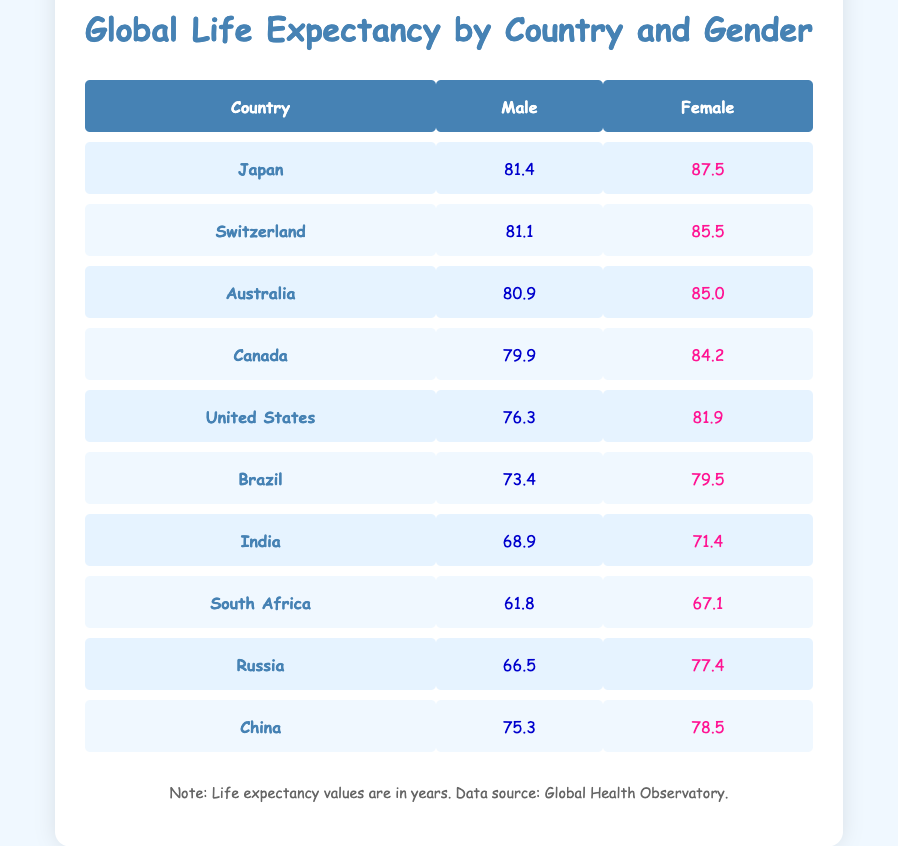What is the life expectancy for females in Japan? The table shows that the life expectancy for females in Japan is 87.5 years, as listed in the row for Japan under the female column.
Answer: 87.5 Which country has the lowest life expectancy for males? Looking at the male column, South Africa has the lowest life expectancy at 61.8 years, as no other country has a value lower than that in the male category.
Answer: 61.8 What is the average life expectancy for females across all countries listed? To find the average, sum the female life expectancies: (87.5 + 85.5 + 85.0 + 84.2 + 81.9 + 79.5 + 71.4 + 67.1 + 77.4 + 78.5) =  818.6. There are 10 countries, so the average is 818.6 / 10 = 81.86 years.
Answer: 81.86 Is the life expectancy for males in Canada higher than that in the United States? The table shows that male life expectancy in Canada is 79.9 years, while in the United States it is 76.3 years. Thus, male life expectancy in Canada is higher.
Answer: Yes What is the difference in life expectancy for females between Brazil and Russia? The life expectancy for females in Brazil is 79.5 years, and for Russia, it is 77.4 years. The difference is calculated as 79.5 - 77.4 = 2.1 years.
Answer: 2.1 Which country has a male life expectancy above 75 years and below 82 years? The countries that fit this criteria are Switzerland (81.1) and Australia (80.9), as their male life expectancies are both above 75 but below 82.
Answer: Switzerland and Australia What is the total life expectancy for all males in the table? We sum the male life expectancies: (81.4 + 81.1 + 80.9 + 79.9 + 76.3 + 73.4 + 68.9 + 61.8 + 66.5 + 75.3) =  775.8 years.
Answer: 775.8 Are there more countries with a female life expectancy over 85 years than those under 70 years? Yes, the countries with female life expectancies over 85 years are Japan, Switzerland, Australia, and Canada (4 countries). Those under 70 years are India and South Africa (2 countries). Thus, there are more countries above 85.
Answer: Yes Which gender has a higher life expectancy in China? The table shows that males in China have a life expectancy of 75.3 years and females have 78.5 years. Since 78.5 is greater than 75.3, females have a higher life expectancy in China.
Answer: Female 